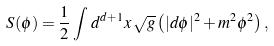Convert formula to latex. <formula><loc_0><loc_0><loc_500><loc_500>S ( \phi ) = \frac { 1 } { 2 } \int \, d ^ { d + 1 } x \, \sqrt { g } \left ( | d \phi | ^ { 2 } + m ^ { 2 } \phi ^ { 2 } \right ) ,</formula> 